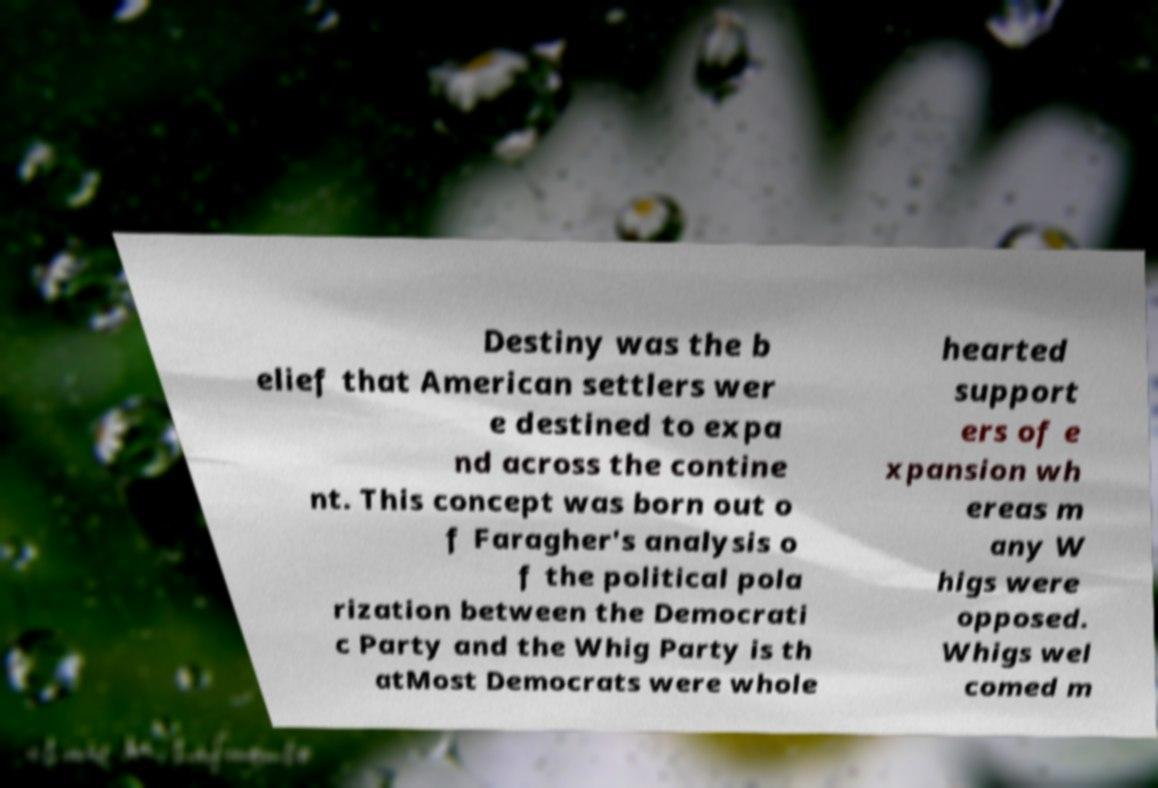Please identify and transcribe the text found in this image. Destiny was the b elief that American settlers wer e destined to expa nd across the contine nt. This concept was born out o f Faragher's analysis o f the political pola rization between the Democrati c Party and the Whig Party is th atMost Democrats were whole hearted support ers of e xpansion wh ereas m any W higs were opposed. Whigs wel comed m 